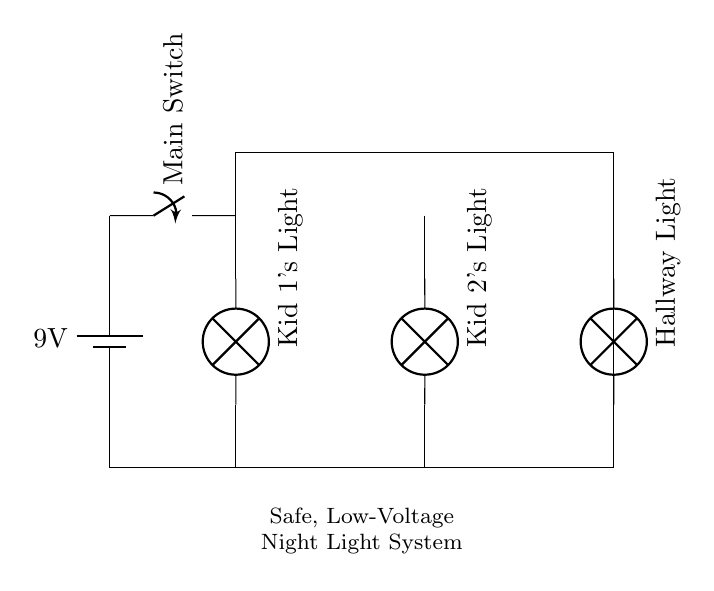What is the voltage of this circuit? The voltage is 9V, which is the potential supplied by the battery in the circuit.
Answer: 9V What type of circuit is shown here? This is a parallel circuit, as indicated by the arrangement of the lights which are connected across the same voltage source rather than in a series configuration.
Answer: Parallel How many night lights are connected in this circuit? There are three night lights connected in this circuit, as shown in the diagram.
Answer: Three What is the purpose of the main switch in this circuit? The main switch allows for the control of the entire night light system, enabling or disabling power to all lights at once.
Answer: Control If one night light fails, will the others still operate? Yes, in a parallel circuit if one light fails, the others will still operate because they are connected independently to the voltage source.
Answer: Yes What is the rating of the battery used in this circuit? The battery rating is 9V, which provides the required electrical energy for the night lights in the system.
Answer: 9V 